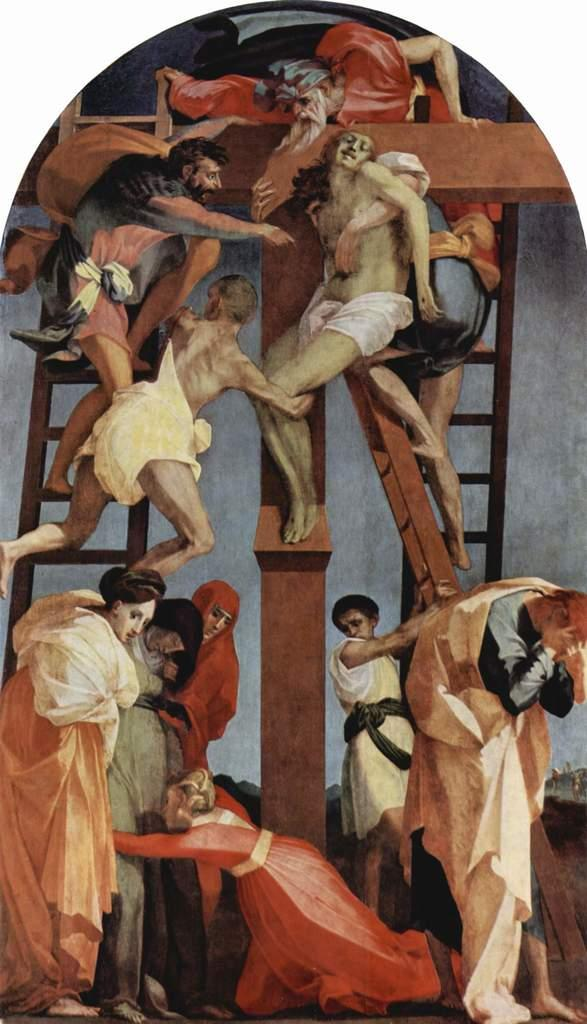What is the main subject of the image? The main subject of the image is an art piece. What does the art piece depict? The art piece depicts a few people. Are there any specific symbols or elements in the art piece? Yes, the art piece includes a cross symbol and features ladders. What type of stone is used to make the soup in the image? There is no soup present in the image, and therefore no stone used to make it. 